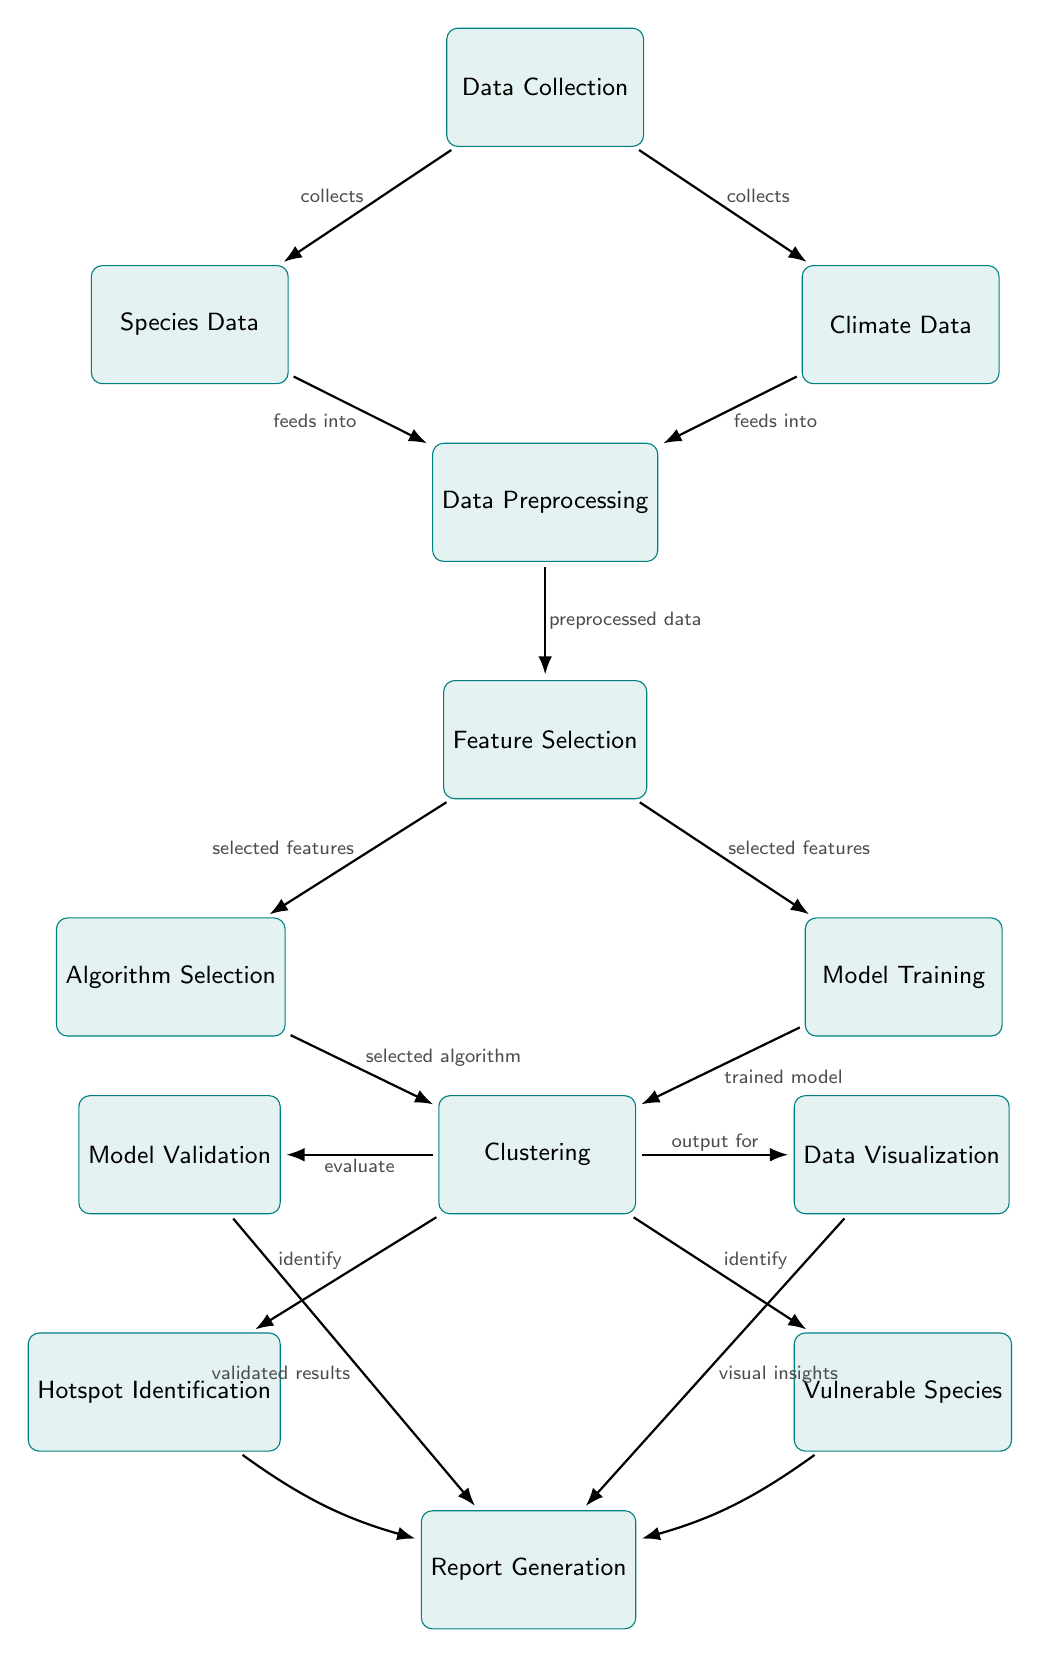What are the two types of data collected? The diagram indicates that Data Collection results in two specific outputs: Species Data and Climate Data. These nodes are directly below the Data Collection node and are connected by arrows indicating a collection relationship.
Answer: Species Data, Climate Data How many nodes are there in total? Counting all the nodes in the diagram, which includes Data Collection, Species Data, Climate Data, Data Preprocessing, Feature Selection, Algorithm Selection, Model Training, Clustering, Hotspot Identification, Vulnerable Species, Model Validation, Data Visualization, and Report Generation, results in a total of 13 nodes.
Answer: 13 What is the output of the Clustering step? The Clustering step produces outputs for Hotspot Identification and Vulnerable Species, indicated by the arrows that lead from Clustering to these two nodes. Each output node is marked with "identify."
Answer: Hotspot Identification, Vulnerable Species Which node feeds into Model Training? In the diagram, the Model Training node receives input from the Feature Selection node, as indicated by the directed arrow from Feature Selection to Model Training. The label on the arrow is "selected features."
Answer: Feature Selection What links Clustering to Report Generation? Clustering connects to Report Generation through the outputs of Hotspot Identification, Vulnerable Species, and by validating results via Model Validation and visual insights via Data Visualization. The arrows represent the flow of information that ultimately leads to Report Generation.
Answer: Hotspot Identification, Vulnerable Species, Model Validation, Data Visualization What is the purpose of Data Preprocessing? The purpose of Data Preprocessing, as indicated in the diagram, is to prepare the Species Data and Climate Data before moving to the next steps. It is the stage where raw data is transformed into preprocessed data, ready for further analysis in Feature Selection.
Answer: Preprocessed data Which step follows Feature Selection? Following Feature Selection in the diagram are two subsequent steps: Algorithm Selection and Model Training. An arrow leads to each of these nodes, indicating that the selected features are used to determine the appropriate algorithm and to train the model.
Answer: Algorithm Selection, Model Training How is the Clustering model validated? The validation of the Clustering model occurs through the Model Validation node, which receives input from Clustering and results in validated results that are directed towards Report Generation. This validation ensures the model's effectiveness before reporting.
Answer: Model Validation What does the Data Visualization step provide? The Data Visualization step provides visual insights, as indicated by the arrow pointing from Visualization to Report Generation. This means that it takes the processed data and presents it in a way that enhances understanding and report preparation.
Answer: Visual insights 